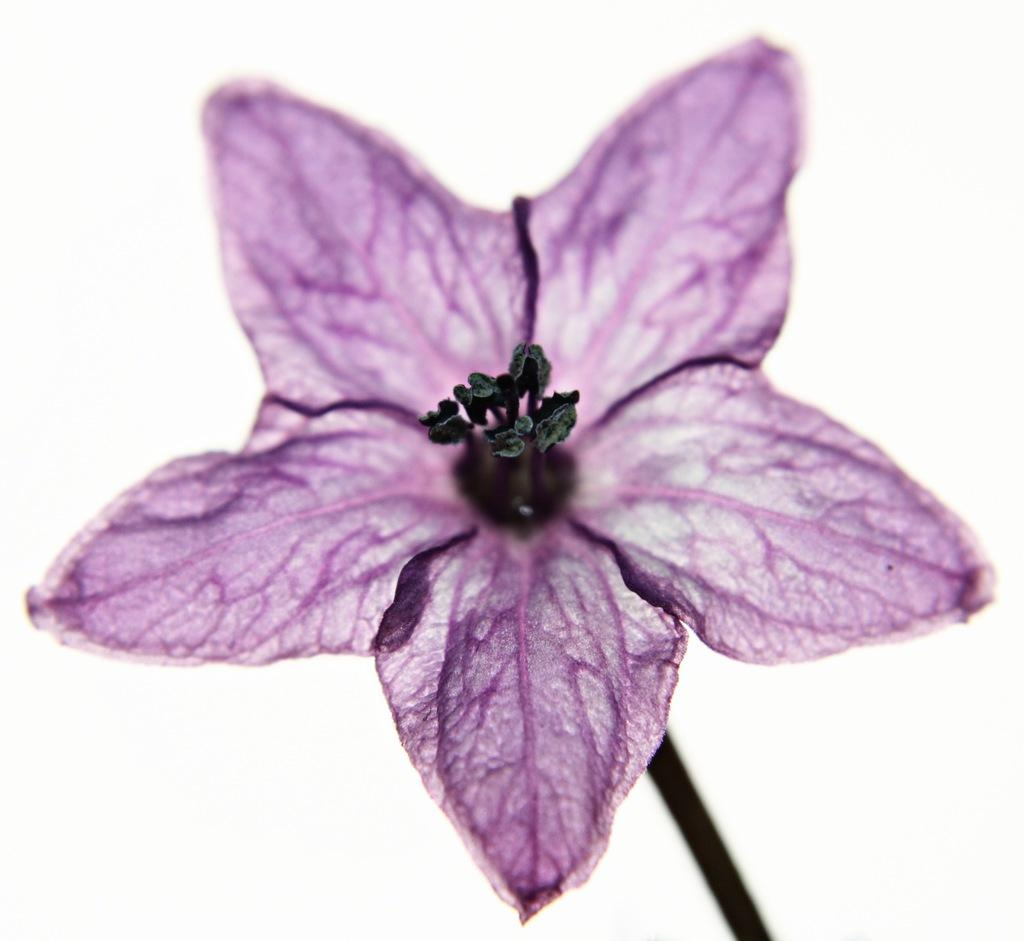What type of flower is in the image? There is a purple flower in the image. What stage of growth are some of the flowers in the image? There are buds in the image. What color is the background of the image? The background of the image is white. What route does the stream take through the image? There is no stream present in the image. 